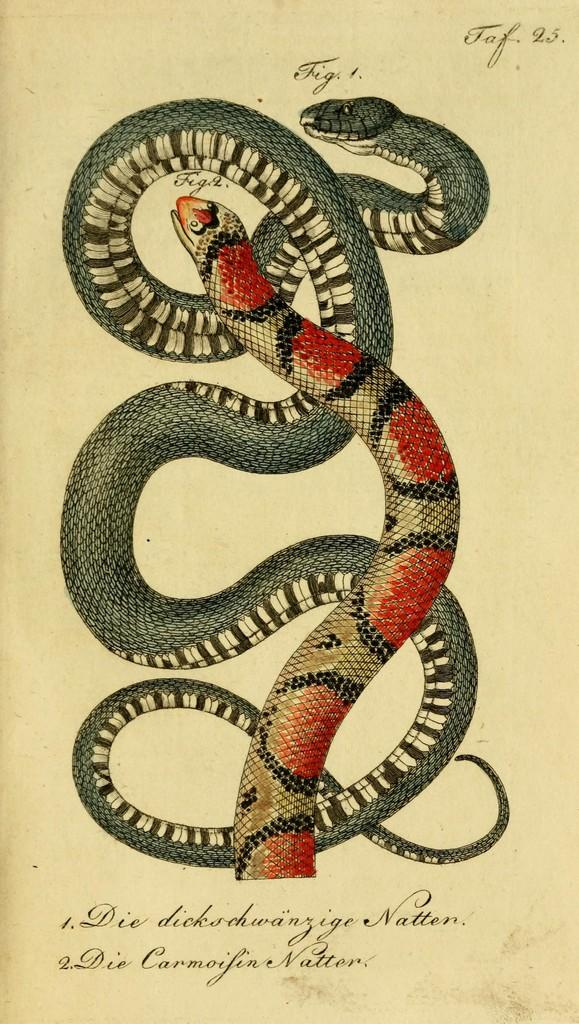What is the main subject of the paper in the image? The paper contains a depiction of snakes. What else can be found on the paper besides the image of snakes? There is text on the paper. What type of attention is the scene in the image trying to capture? There is no scene present in the image, only a paper with a depiction of snakes and text. What is the pot used for in the image? There is no pot present in the image. 